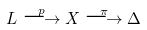Convert formula to latex. <formula><loc_0><loc_0><loc_500><loc_500>L \overset { p } { \longrightarrow } X \overset { \pi } { \longrightarrow } \Delta</formula> 